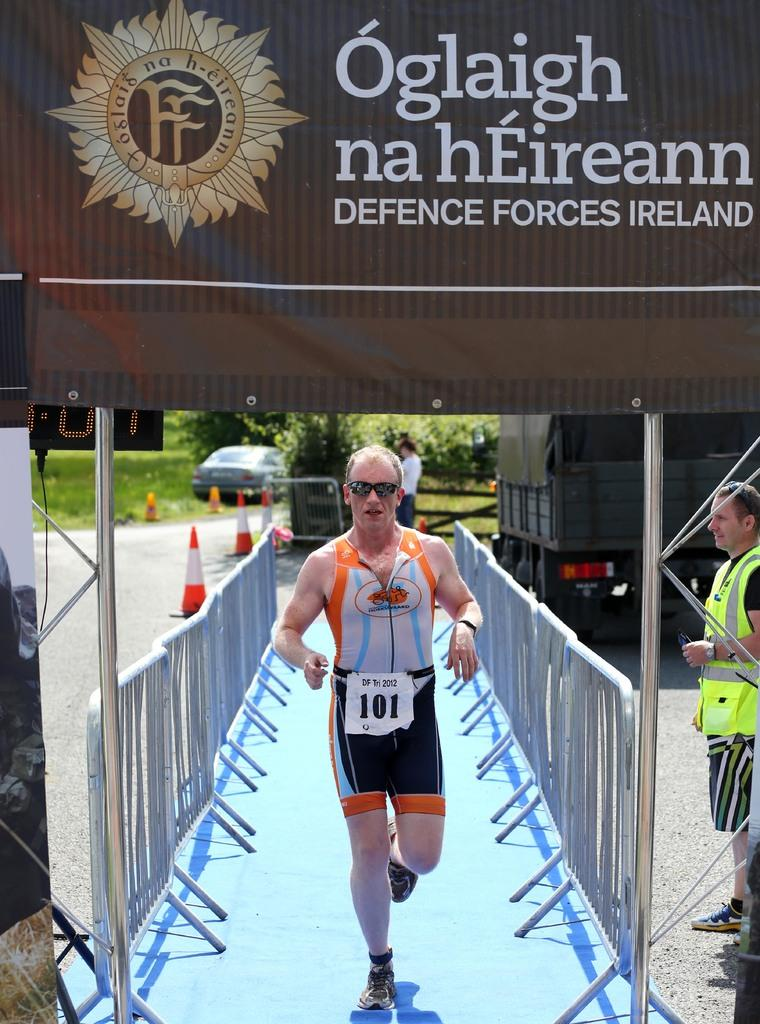Provide a one-sentence caption for the provided image. Runner number 101 goes between two sets of barriers on a blue rug. 